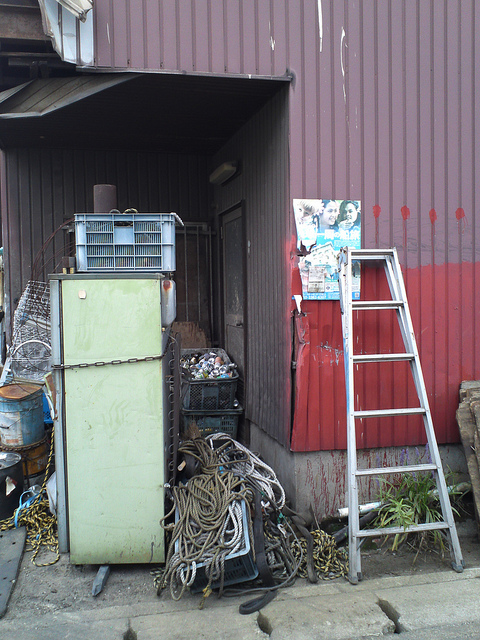<image>Why isn't someone getting rid of all this junk? It is unknown why isn't someone getting rid of all this junk. It can be seen that someone might be a hoarder. Why isn't someone getting rid of all this junk? It is unknown why someone isn't getting rid of all this junk. It can be because they are hoarders, they might need it, or they find it useful. 